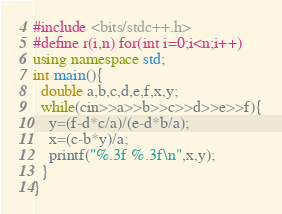<code> <loc_0><loc_0><loc_500><loc_500><_C++_>#include <bits/stdc++.h>
#define r(i,n) for(int i=0;i<n;i++)
using namespace std;
int main(){
  double a,b,c,d,e,f,x,y;
  while(cin>>a>>b>>c>>d>>e>>f){
    y=(f-d*c/a)/(e-d*b/a);
    x=(c-b*y)/a;
    printf("%.3f %.3f\n",x,y);
  }
}</code> 